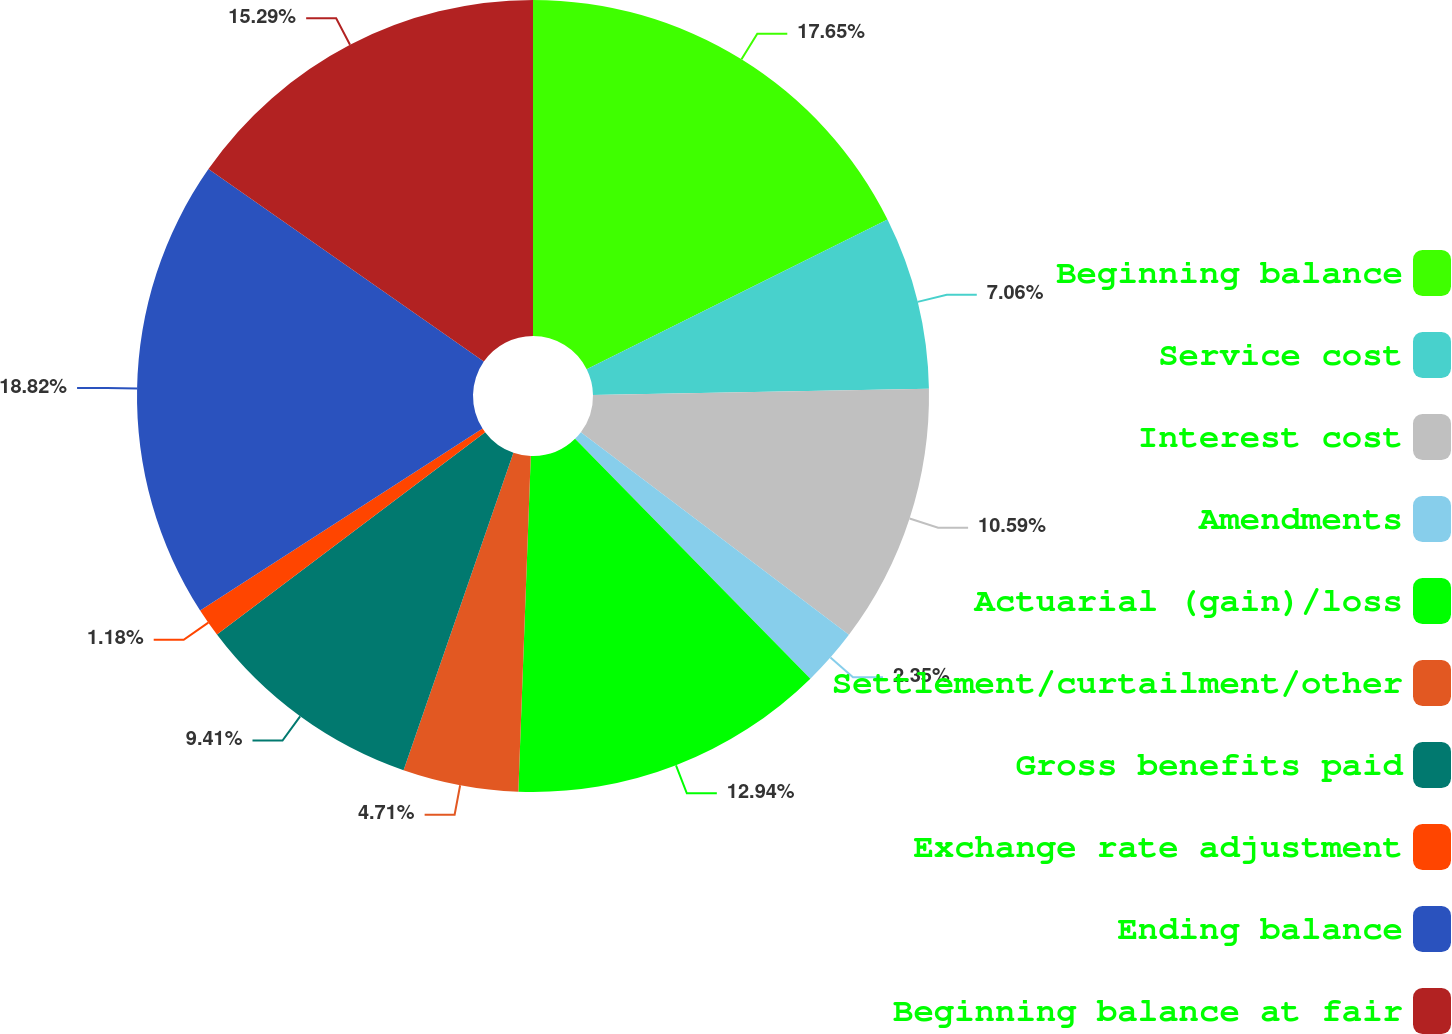Convert chart. <chart><loc_0><loc_0><loc_500><loc_500><pie_chart><fcel>Beginning balance<fcel>Service cost<fcel>Interest cost<fcel>Amendments<fcel>Actuarial (gain)/loss<fcel>Settlement/curtailment/other<fcel>Gross benefits paid<fcel>Exchange rate adjustment<fcel>Ending balance<fcel>Beginning balance at fair<nl><fcel>17.65%<fcel>7.06%<fcel>10.59%<fcel>2.35%<fcel>12.94%<fcel>4.71%<fcel>9.41%<fcel>1.18%<fcel>18.82%<fcel>15.29%<nl></chart> 